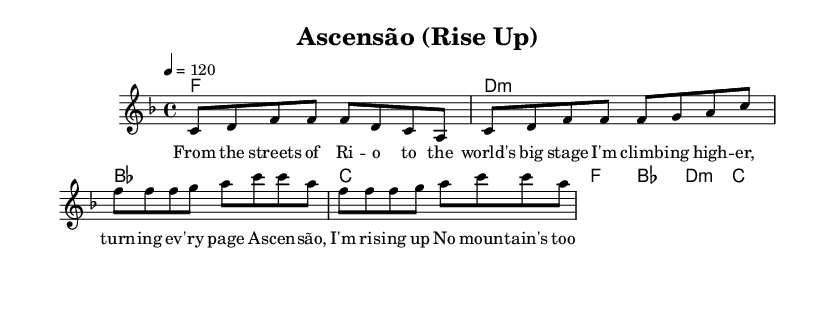What is the key signature of this music? The key signature is F major, which contains one flat (B flat). This can be determined by looking at the key signature indicated at the beginning of the score, marked right after 'global'.
Answer: F major What is the time signature of this music? The time signature is 4/4, as indicated at the start of the score. This means there are four beats in a measure, and the quarter note gets one beat.
Answer: 4/4 What is the tempo of the piece? The tempo is marked as 120 beats per minute, indicated by '4 = 120' in the global section of the score. This means that there are 120 quarter note beats in a minute.
Answer: 120 How many bars are in the verse section? The verse section consists of 4 bars, where the melody and chord progressions for the verse indicate how many measures are present. Counting the measures in the 'melody' and 'verseChords' sections confirms this.
Answer: 4 What is the first word of the chorus lyrics? The chorus lyrics start with the word "As," which is the first lyric under the chorus section in the score. This can be seen clearly below the chorus melody notes.
Answer: As What type of chords are used in the chorus? The chords in the chorus include F major, B flat major, D minor, and C major. These chord names are explicitly stated in the 'chorusChords' section.
Answer: F, B flat, D minor, C How does the mood of this song relate to its theme of overcoming challenges? The song's upbeat nature and affirmative lyrics evoke a positive and determined mood, which relates to the theme of overcoming obstacles and achieving goals expressed in the message of rising up against challenges. This can be inferred from the lyrics and the energetic tempo.
Answer: Upbeat and affirmative 